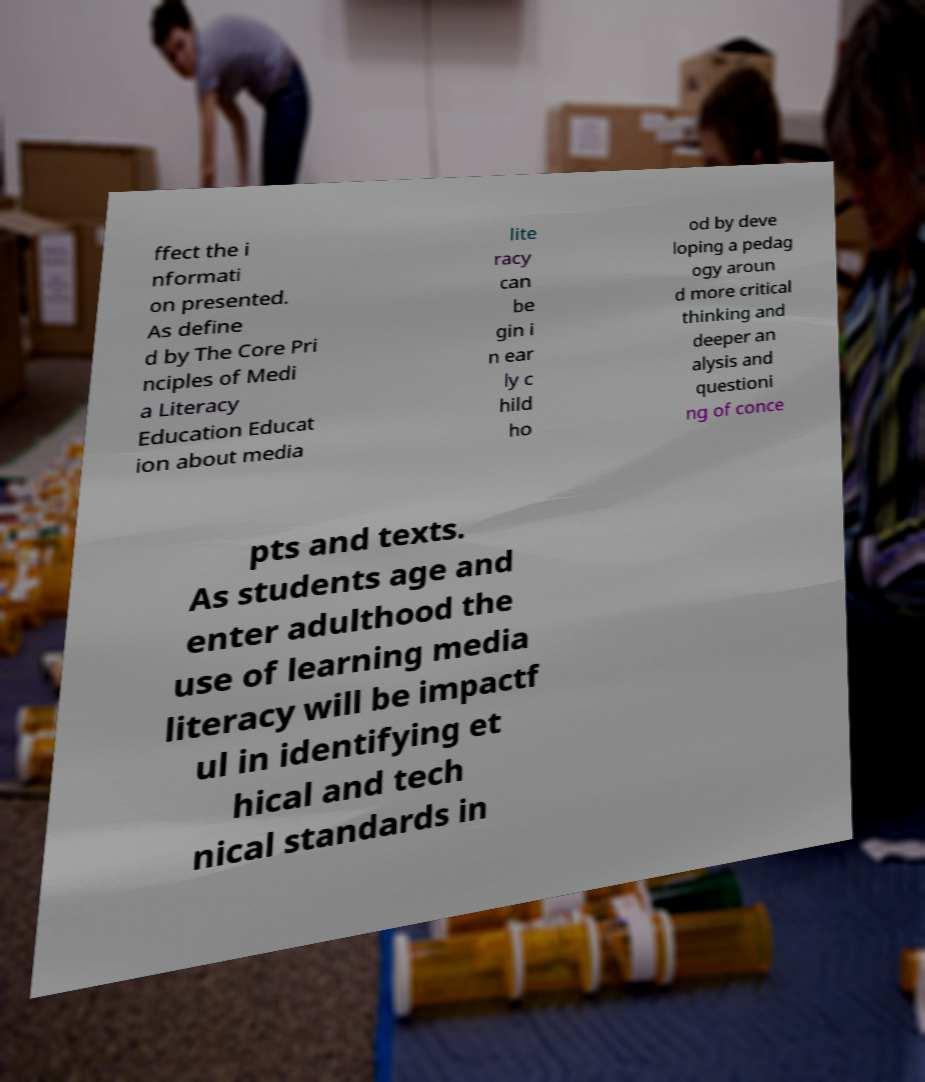What messages or text are displayed in this image? I need them in a readable, typed format. ffect the i nformati on presented. As define d by The Core Pri nciples of Medi a Literacy Education Educat ion about media lite racy can be gin i n ear ly c hild ho od by deve loping a pedag ogy aroun d more critical thinking and deeper an alysis and questioni ng of conce pts and texts. As students age and enter adulthood the use of learning media literacy will be impactf ul in identifying et hical and tech nical standards in 